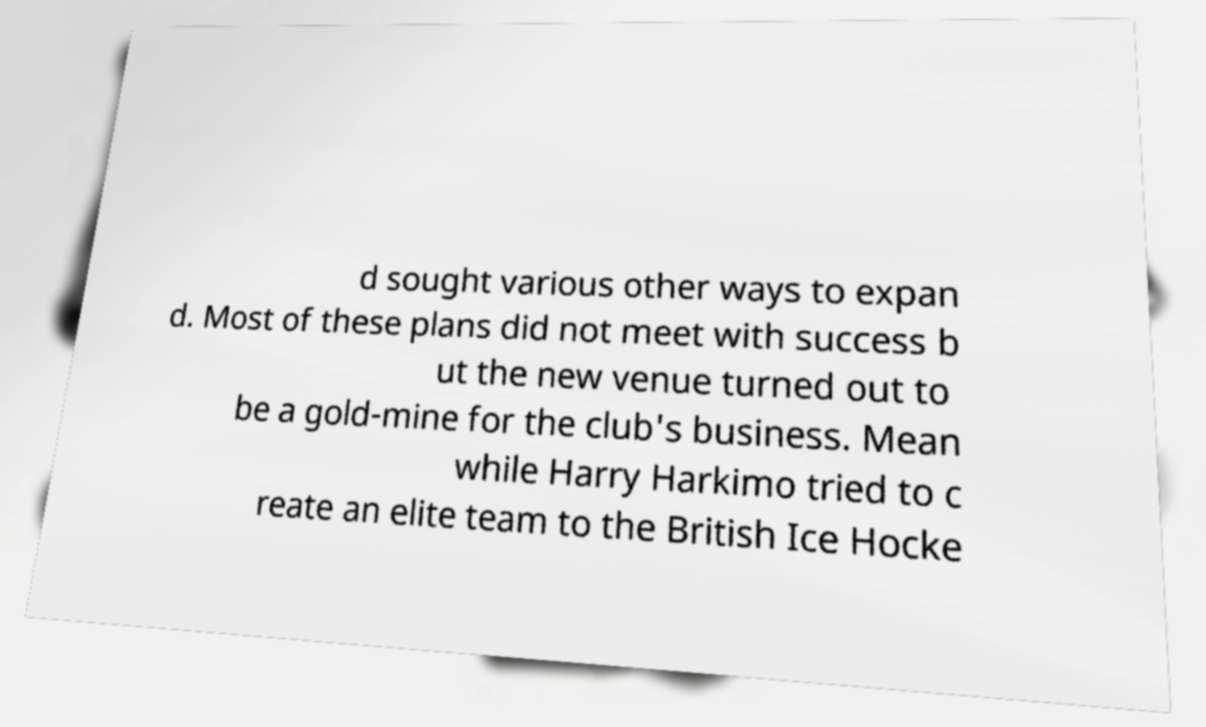Could you assist in decoding the text presented in this image and type it out clearly? d sought various other ways to expan d. Most of these plans did not meet with success b ut the new venue turned out to be a gold-mine for the club's business. Mean while Harry Harkimo tried to c reate an elite team to the British Ice Hocke 